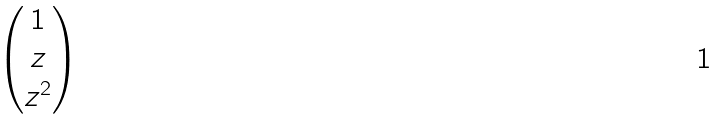Convert formula to latex. <formula><loc_0><loc_0><loc_500><loc_500>\begin{pmatrix} 1 \\ z \\ z ^ { 2 } \end{pmatrix}</formula> 